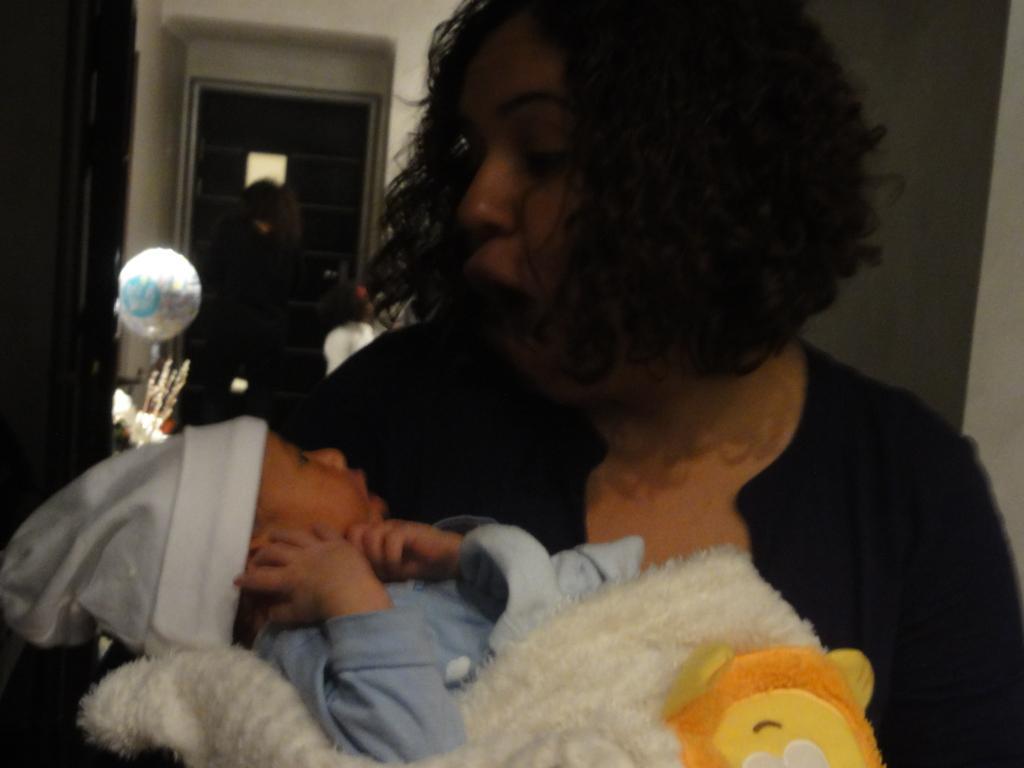Please provide a concise description of this image. In this image, I can see a person carrying a baby. In the background, I can see a balloon and there are two persons standing near a door. 